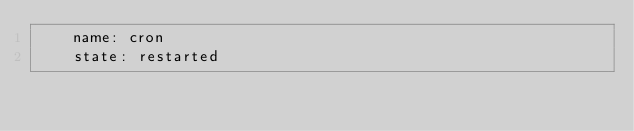Convert code to text. <code><loc_0><loc_0><loc_500><loc_500><_YAML_>    name: cron
    state: restarted
</code> 